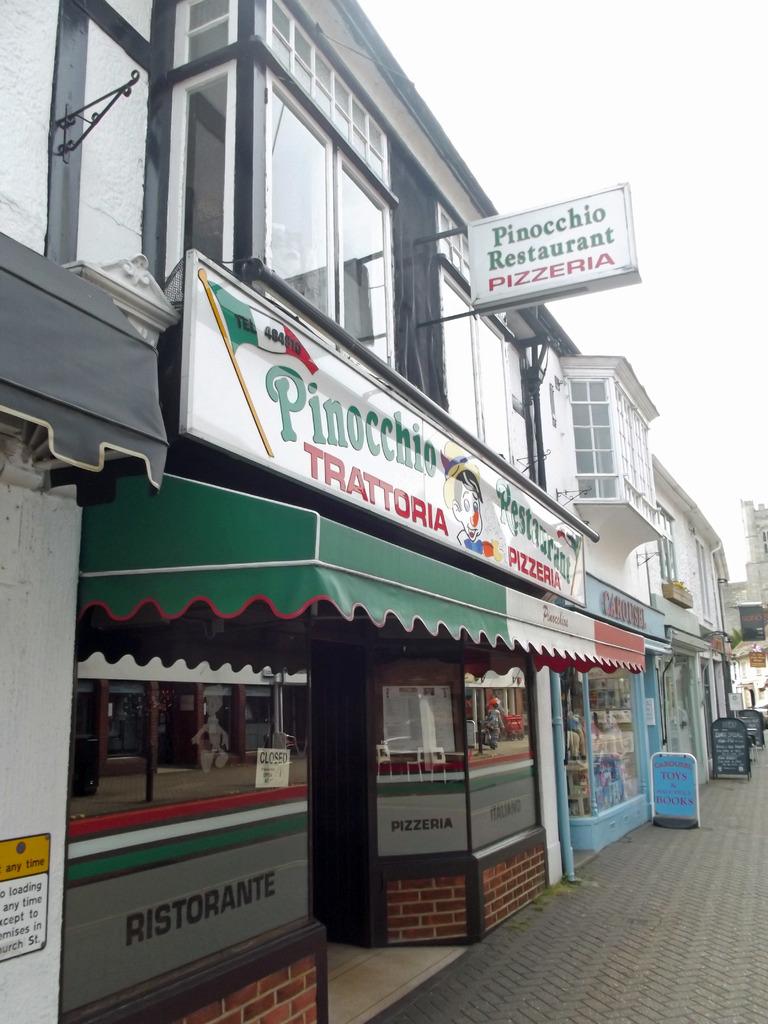What type of cuisine does this restaurant offer?
Make the answer very short. Pizza. What is the name of the restaurant?
Offer a very short reply. Pinocchio restaurant. 